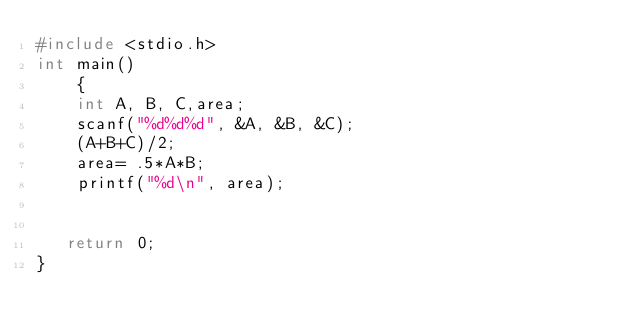Convert code to text. <code><loc_0><loc_0><loc_500><loc_500><_C_>#include <stdio.h>
int main()
    {
    int A, B, C,area;
    scanf("%d%d%d", &A, &B, &C);
    (A+B+C)/2;
    area= .5*A*B;
    printf("%d\n", area);


   return 0;
}

</code> 